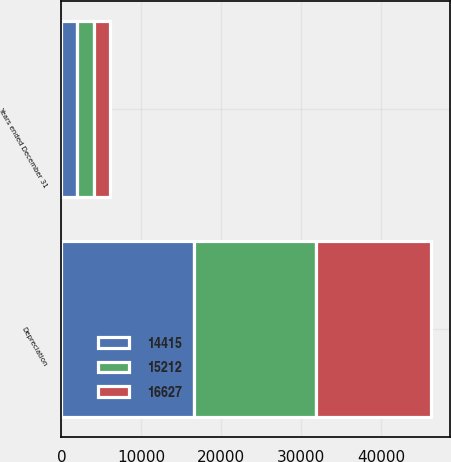Convert chart to OTSL. <chart><loc_0><loc_0><loc_500><loc_500><stacked_bar_chart><ecel><fcel>Years ended December 31<fcel>Depreciation<nl><fcel>14415<fcel>2014<fcel>16627<nl><fcel>16627<fcel>2013<fcel>14415<nl><fcel>15212<fcel>2012<fcel>15212<nl></chart> 